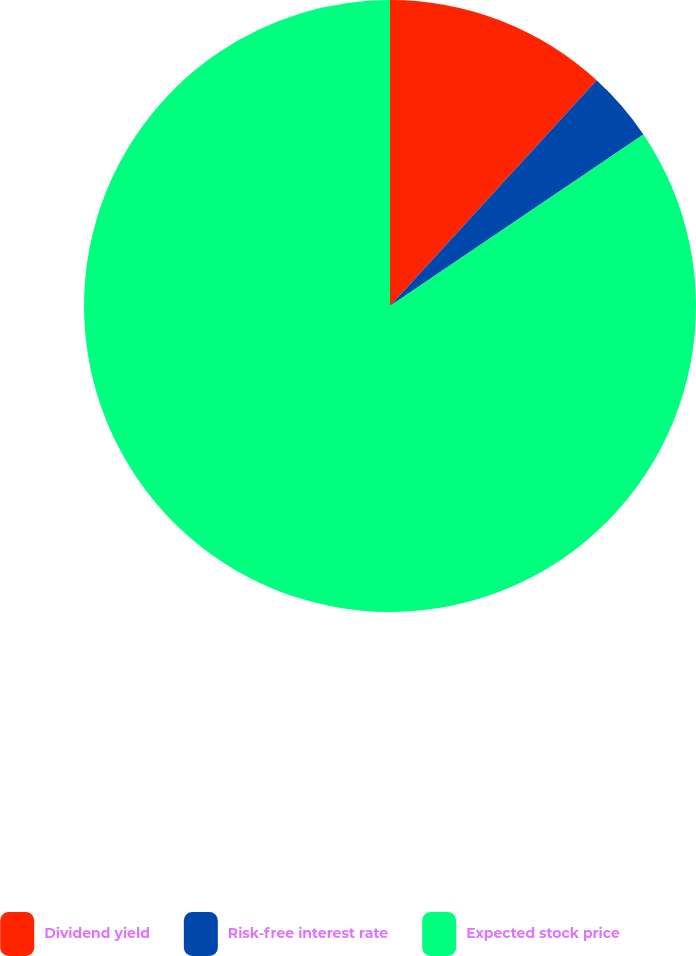Convert chart to OTSL. <chart><loc_0><loc_0><loc_500><loc_500><pie_chart><fcel>Dividend yield<fcel>Risk-free interest rate<fcel>Expected stock price<nl><fcel>11.8%<fcel>3.73%<fcel>84.46%<nl></chart> 